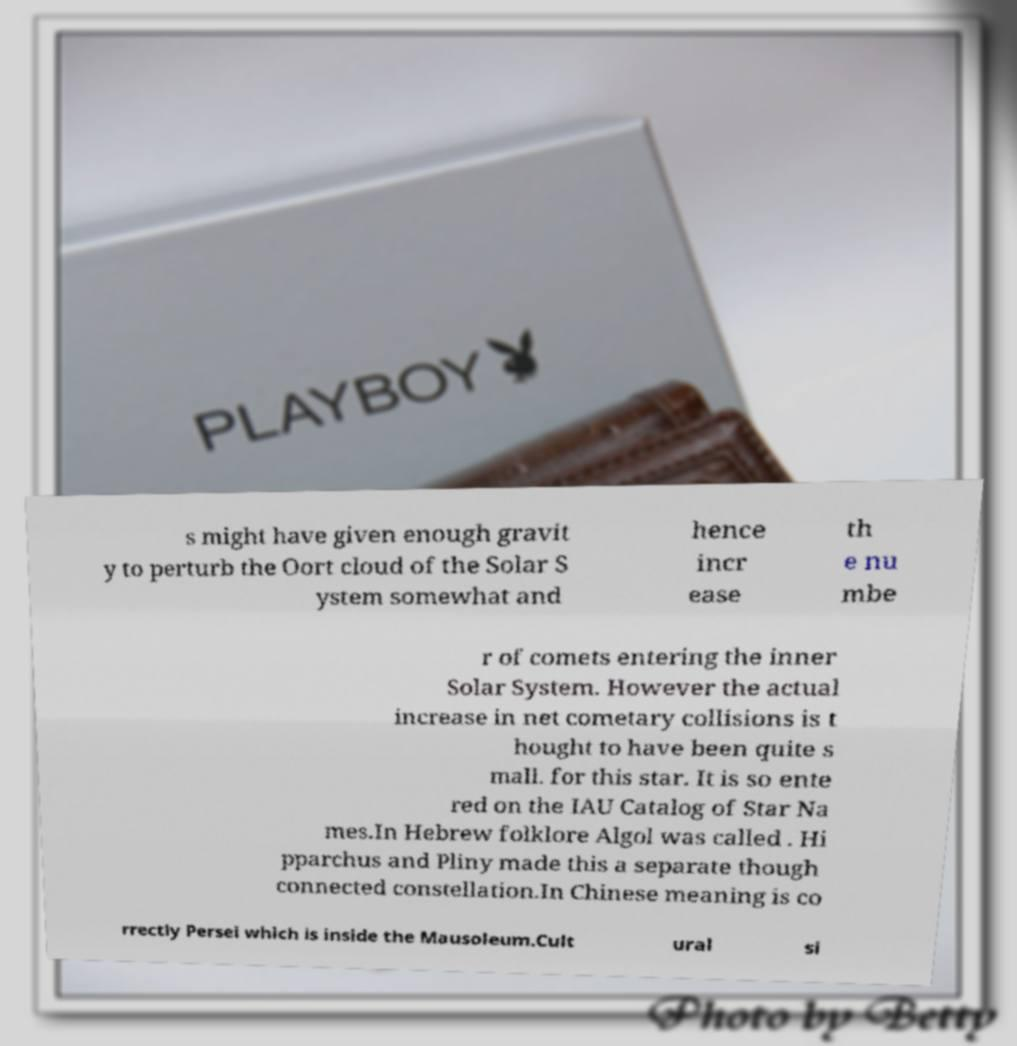Can you accurately transcribe the text from the provided image for me? s might have given enough gravit y to perturb the Oort cloud of the Solar S ystem somewhat and hence incr ease th e nu mbe r of comets entering the inner Solar System. However the actual increase in net cometary collisions is t hought to have been quite s mall. for this star. It is so ente red on the IAU Catalog of Star Na mes.In Hebrew folklore Algol was called . Hi pparchus and Pliny made this a separate though connected constellation.In Chinese meaning is co rrectly Persei which is inside the Mausoleum.Cult ural si 